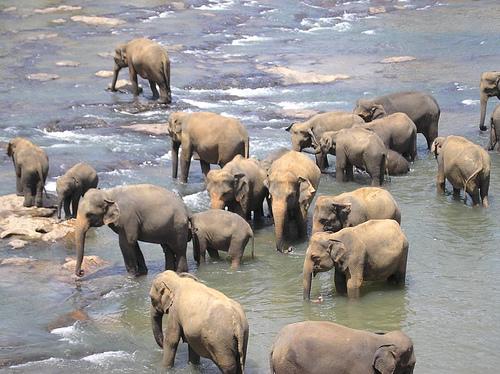How many elephants constant?
Give a very brief answer. 20. Do these animals appear to be in the wild?
Concise answer only. Yes. Are the elephants thirsty?
Keep it brief. Yes. 